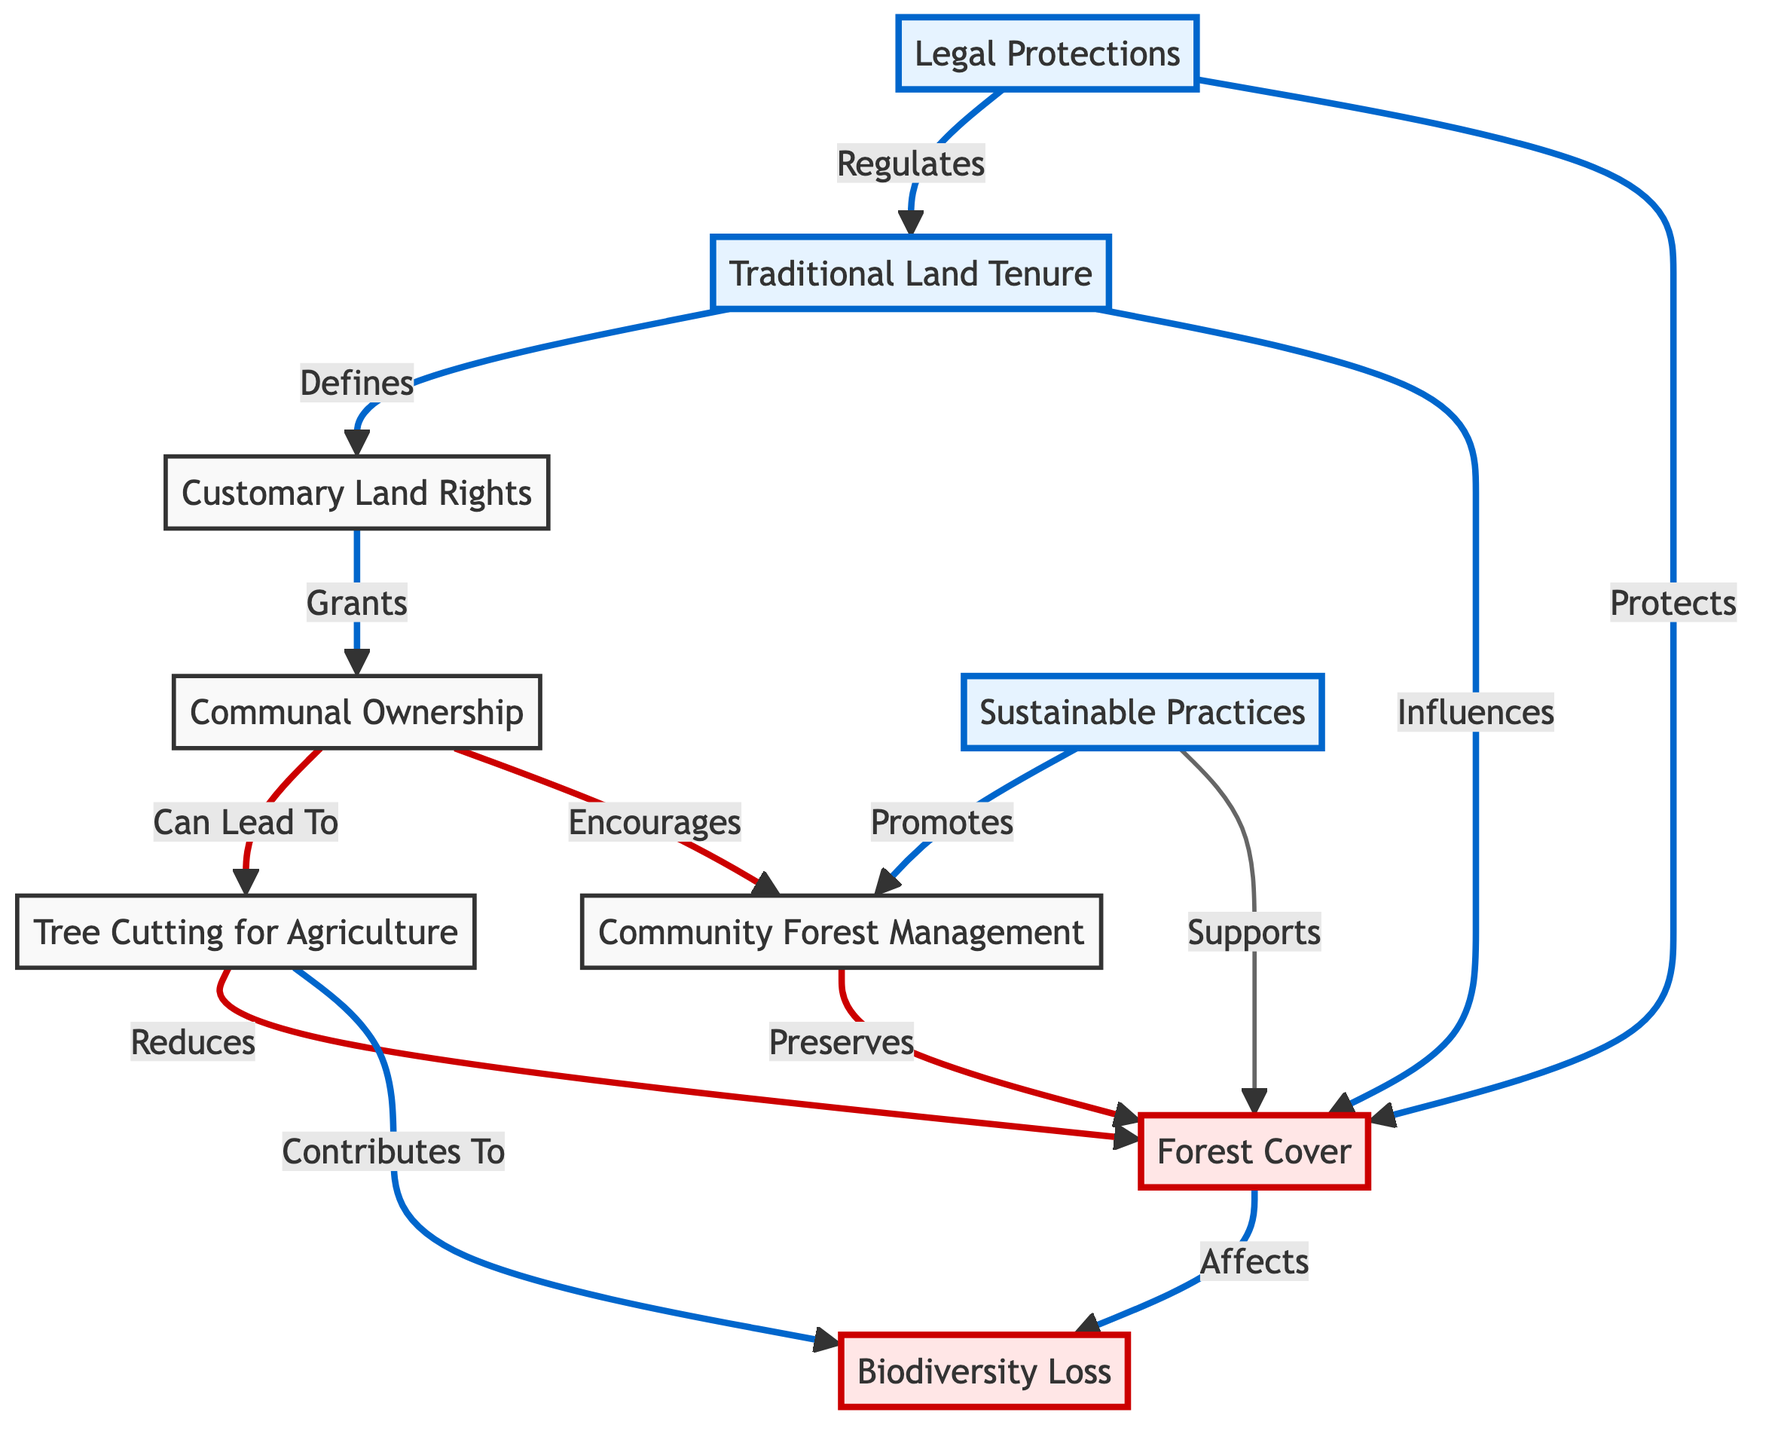What is the main type of land tenure represented in the diagram? The main type of land tenure represented is "Traditional Land Tenure," indicated as the starting point of the flowchart.
Answer: Traditional Land Tenure How many nodes are present in the diagram? By counting each distinct node represented in the diagram, there are a total of nine nodes.
Answer: 9 What does "Customary Land Rights" grant according to the diagram? According to the diagram, "Customary Land Rights" grants "Communal Ownership," as indicated by the directed flow from node 2 to node 3.
Answer: Communal Ownership What effect does "Tree Cutting for Agriculture" have on "Forest Cover"? The diagram indicates that "Tree Cutting for Agriculture" reduces "Forest Cover," as shown by the directed arrow from node 5 leading to node 4.
Answer: Reduces How does "Community Forest Management" affect "Forest Cover"? The diagram states that "Community Forest Management" preserves "Forest Cover," indicated by the directed connection from node 6 to node 4.
Answer: Preserves How does "Legal Protections" relate to "Traditional Land Tenure"? "Legal Protections" regulates "Traditional Land Tenure," as shown by the link from node 8 to node 1.
Answer: Regulates What is a consequence of "Communal Ownership" regarding biodiversity? The diagram shows that "Communal Ownership" contributes to "Biodiversity Loss," indicated by the arrow from node 3 to node 7.
Answer: Biodiversity Loss What do "Sustainable Practices" promote regarding "Community Forest Management"? According to the diagram, "Sustainable Practices" promote "Community Forest Management," indicated by the directed arrow from node 9 to node 6.
Answer: Promote What is the overall impact of "Legal Protections" on "Forest Cover"? The diagram indicates that "Legal Protections" both protects and regulates "Forest Cover," suggesting a positive impact.
Answer: Protects 